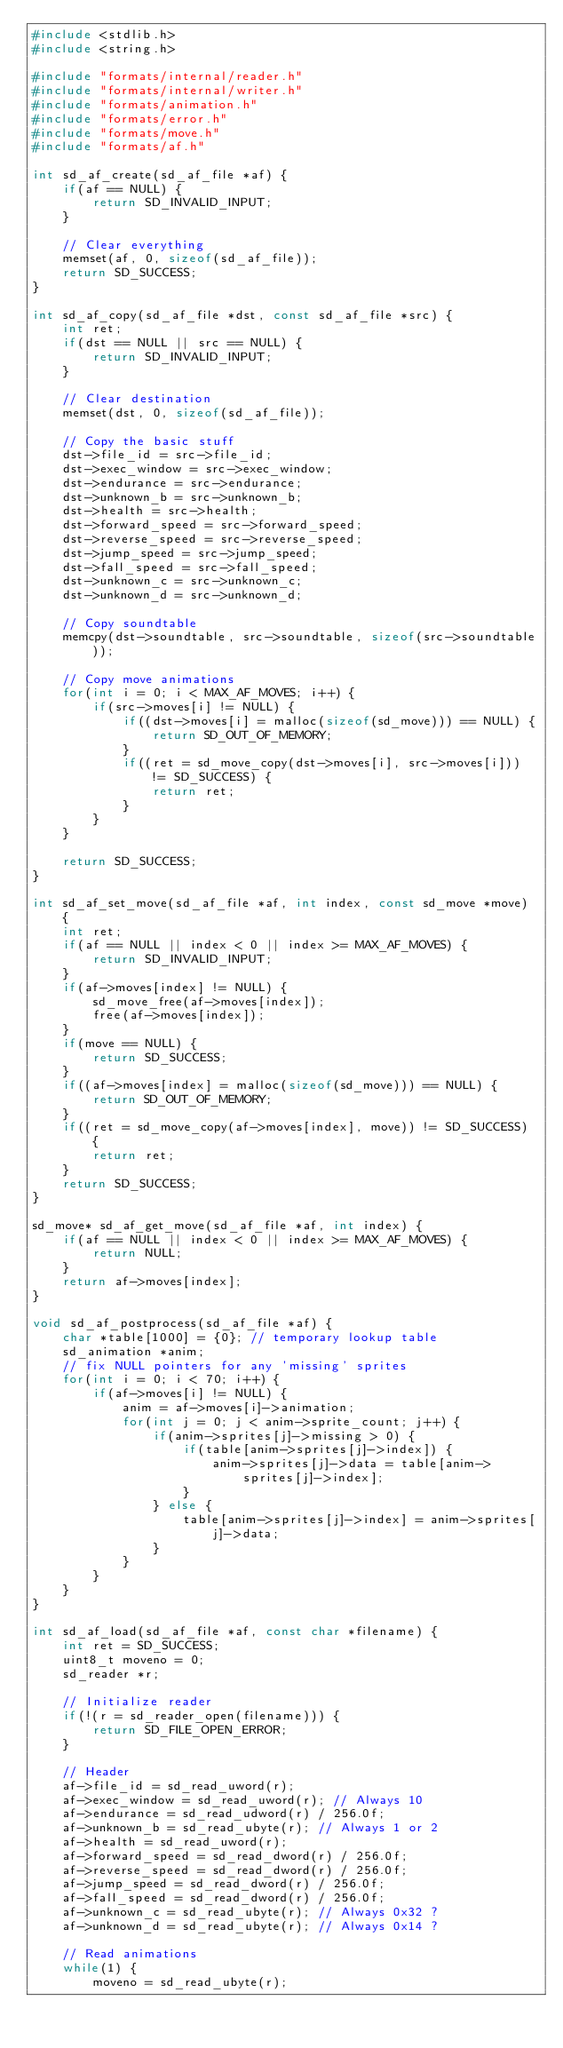<code> <loc_0><loc_0><loc_500><loc_500><_C_>#include <stdlib.h>
#include <string.h>

#include "formats/internal/reader.h"
#include "formats/internal/writer.h"
#include "formats/animation.h"
#include "formats/error.h"
#include "formats/move.h"
#include "formats/af.h"

int sd_af_create(sd_af_file *af) {
    if(af == NULL) {
        return SD_INVALID_INPUT;
    }

    // Clear everything
    memset(af, 0, sizeof(sd_af_file));
    return SD_SUCCESS;
}

int sd_af_copy(sd_af_file *dst, const sd_af_file *src) {
    int ret;
    if(dst == NULL || src == NULL) {
        return SD_INVALID_INPUT;
    }

    // Clear destination
    memset(dst, 0, sizeof(sd_af_file));

    // Copy the basic stuff
    dst->file_id = src->file_id;
    dst->exec_window = src->exec_window;
    dst->endurance = src->endurance;
    dst->unknown_b = src->unknown_b;
    dst->health = src->health;
    dst->forward_speed = src->forward_speed;
    dst->reverse_speed = src->reverse_speed;
    dst->jump_speed = src->jump_speed;
    dst->fall_speed = src->fall_speed;
    dst->unknown_c = src->unknown_c;
    dst->unknown_d = src->unknown_d;

    // Copy soundtable
    memcpy(dst->soundtable, src->soundtable, sizeof(src->soundtable));

    // Copy move animations
    for(int i = 0; i < MAX_AF_MOVES; i++) {
        if(src->moves[i] != NULL) {
            if((dst->moves[i] = malloc(sizeof(sd_move))) == NULL) {
                return SD_OUT_OF_MEMORY;
            }
            if((ret = sd_move_copy(dst->moves[i], src->moves[i])) != SD_SUCCESS) {
                return ret;
            }
        }
    }

    return SD_SUCCESS;
}

int sd_af_set_move(sd_af_file *af, int index, const sd_move *move) {
    int ret;
    if(af == NULL || index < 0 || index >= MAX_AF_MOVES) {
        return SD_INVALID_INPUT;
    }
    if(af->moves[index] != NULL) {
        sd_move_free(af->moves[index]);
        free(af->moves[index]);
    }
    if(move == NULL) {
        return SD_SUCCESS;
    }
    if((af->moves[index] = malloc(sizeof(sd_move))) == NULL) {
        return SD_OUT_OF_MEMORY;
    }
    if((ret = sd_move_copy(af->moves[index], move)) != SD_SUCCESS) {
        return ret;
    }
    return SD_SUCCESS;
}

sd_move* sd_af_get_move(sd_af_file *af, int index) {
    if(af == NULL || index < 0 || index >= MAX_AF_MOVES) {
        return NULL;
    }
    return af->moves[index];
}

void sd_af_postprocess(sd_af_file *af) {
    char *table[1000] = {0}; // temporary lookup table
    sd_animation *anim;
    // fix NULL pointers for any 'missing' sprites
    for(int i = 0; i < 70; i++) {
        if(af->moves[i] != NULL) {
            anim = af->moves[i]->animation;
            for(int j = 0; j < anim->sprite_count; j++) {
                if(anim->sprites[j]->missing > 0) {
                    if(table[anim->sprites[j]->index]) {
                        anim->sprites[j]->data = table[anim->sprites[j]->index];
                    }
                } else {
                    table[anim->sprites[j]->index] = anim->sprites[j]->data;
                }
            }
        }
    }
}

int sd_af_load(sd_af_file *af, const char *filename) {
    int ret = SD_SUCCESS;
    uint8_t moveno = 0;
    sd_reader *r;

    // Initialize reader
    if(!(r = sd_reader_open(filename))) {
        return SD_FILE_OPEN_ERROR;
    }

    // Header
    af->file_id = sd_read_uword(r);
    af->exec_window = sd_read_uword(r); // Always 10
    af->endurance = sd_read_udword(r) / 256.0f;
    af->unknown_b = sd_read_ubyte(r); // Always 1 or 2
    af->health = sd_read_uword(r);
    af->forward_speed = sd_read_dword(r) / 256.0f;
    af->reverse_speed = sd_read_dword(r) / 256.0f;
    af->jump_speed = sd_read_dword(r) / 256.0f;
    af->fall_speed = sd_read_dword(r) / 256.0f;
    af->unknown_c = sd_read_ubyte(r); // Always 0x32 ?
    af->unknown_d = sd_read_ubyte(r); // Always 0x14 ?

    // Read animations
    while(1) {
        moveno = sd_read_ubyte(r);</code> 